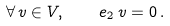Convert formula to latex. <formula><loc_0><loc_0><loc_500><loc_500>\forall \, v \in V , \quad e _ { 2 } \, v = 0 \, .</formula> 